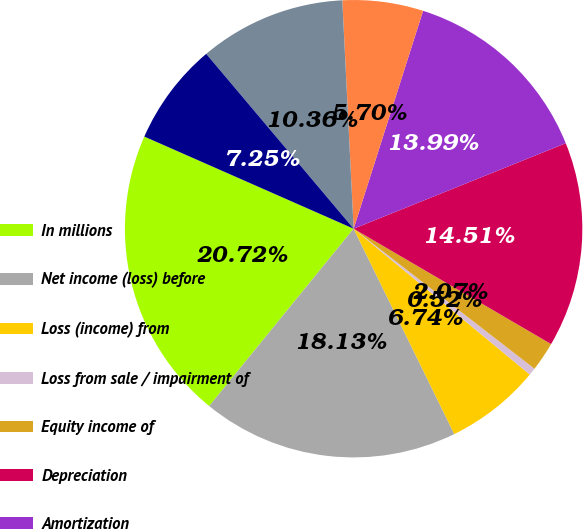Convert chart. <chart><loc_0><loc_0><loc_500><loc_500><pie_chart><fcel>In millions<fcel>Net income (loss) before<fcel>Loss (income) from<fcel>Loss from sale / impairment of<fcel>Equity income of<fcel>Depreciation<fcel>Amortization<fcel>Loss (gain) on sale of<fcel>Deferred income taxes<fcel>Share-based compensation<nl><fcel>20.72%<fcel>18.13%<fcel>6.74%<fcel>0.52%<fcel>2.07%<fcel>14.51%<fcel>13.99%<fcel>5.7%<fcel>10.36%<fcel>7.25%<nl></chart> 